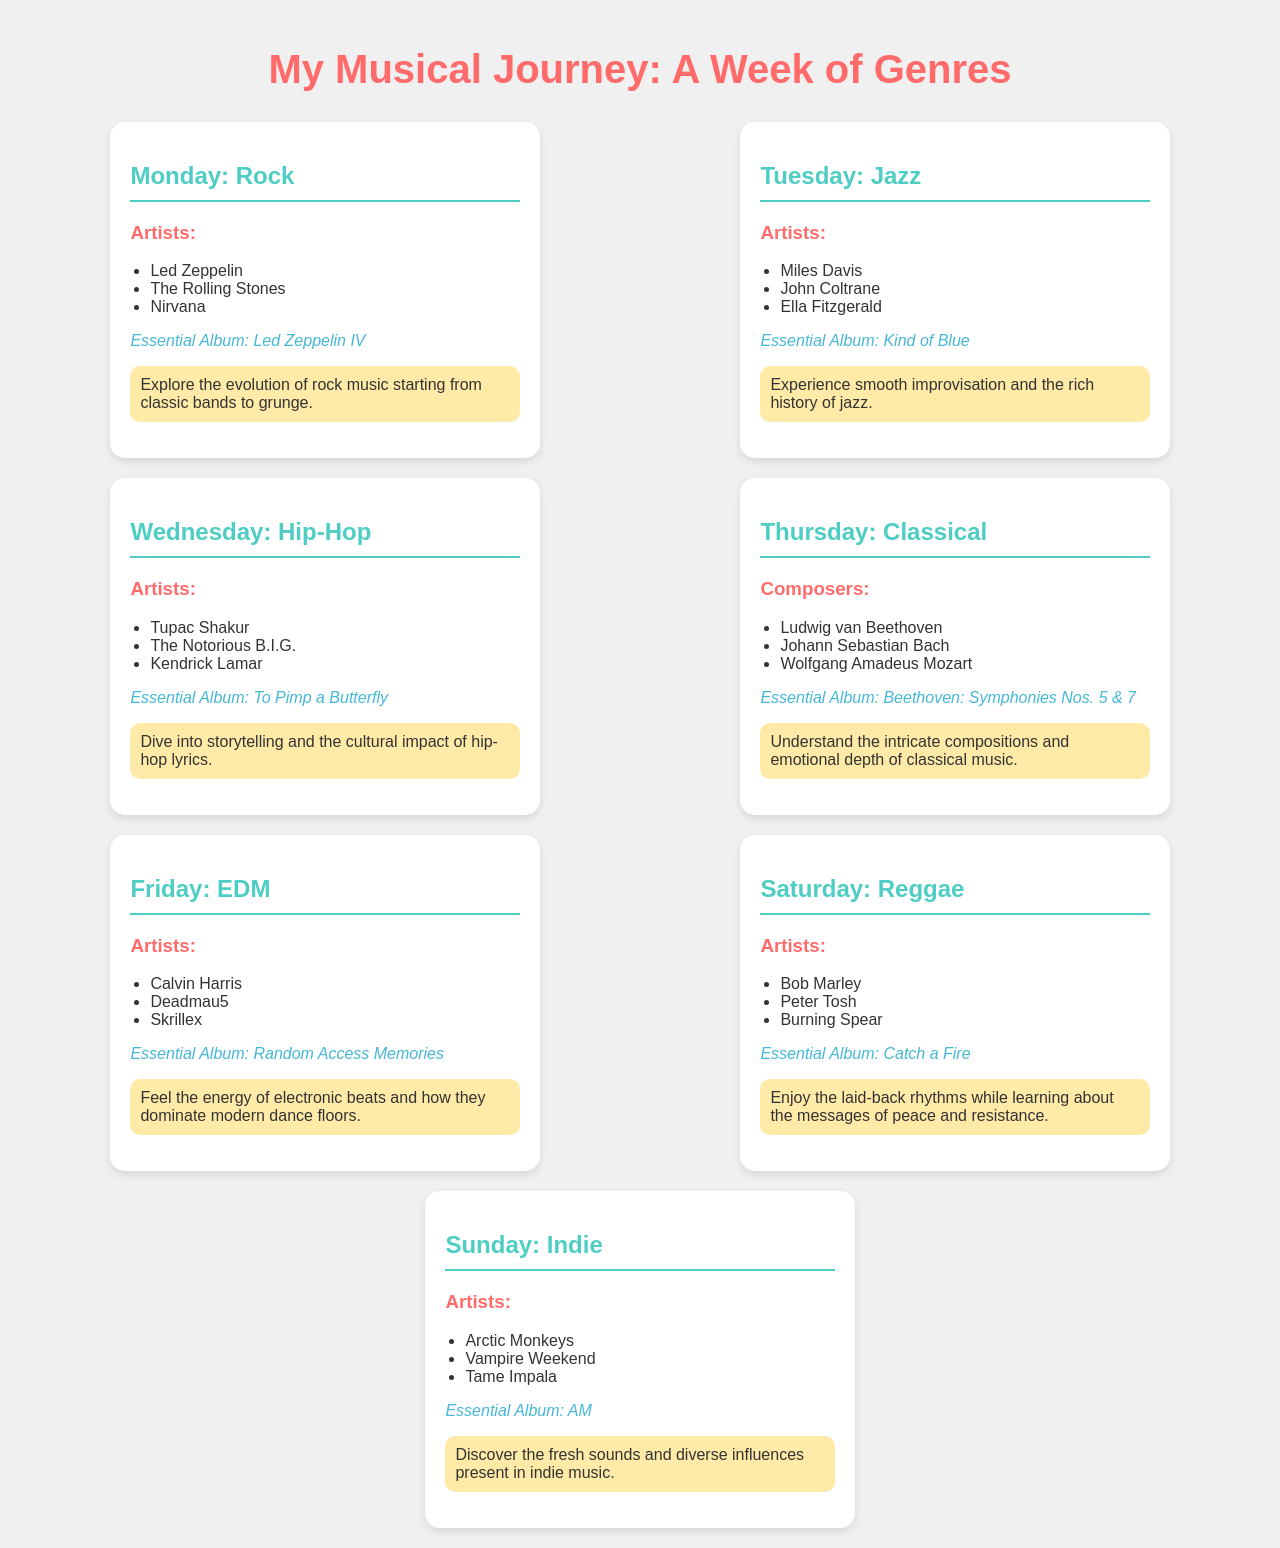What genre is featured on Monday? The genre featured on Monday is Rock, as indicated in the schedule.
Answer: Rock Who is an artist listed under Wednesday's genre? The document provides a list of artists for Wednesday, where one of them is Tupac Shakur.
Answer: Tupac Shakur What is the essential album for Friday? The essential album for Friday's EDM genre is titled Random Access Memories.
Answer: Random Access Memories Which day includes Classical music in the schedule? Classical music is highlighted on Thursday according to the breakdown of genres for the week.
Answer: Thursday Name one artist from the Saturday genre. For Saturday's genre of Reggae, one of the artists listed is Bob Marley.
Answer: Bob Marley How many genres are presented in total throughout the week? The document outlines a total of seven different genres, one for each day of the week.
Answer: Seven What is the experience focus for Tuesday's genre? Tuesday's experience focus is on the smooth improvisation and the rich history of jazz.
Answer: Smooth improvisation and the rich history of jazz Which genre is associated with the essential album "AM"? The essential album "AM" is linked with the Indie genre, as stated for Sunday.
Answer: Indie Who is listed as a composer under Thursday's genre? Among the composers listed under Thursday's classical genre, one is Ludwig van Beethoven.
Answer: Ludwig van Beethoven 